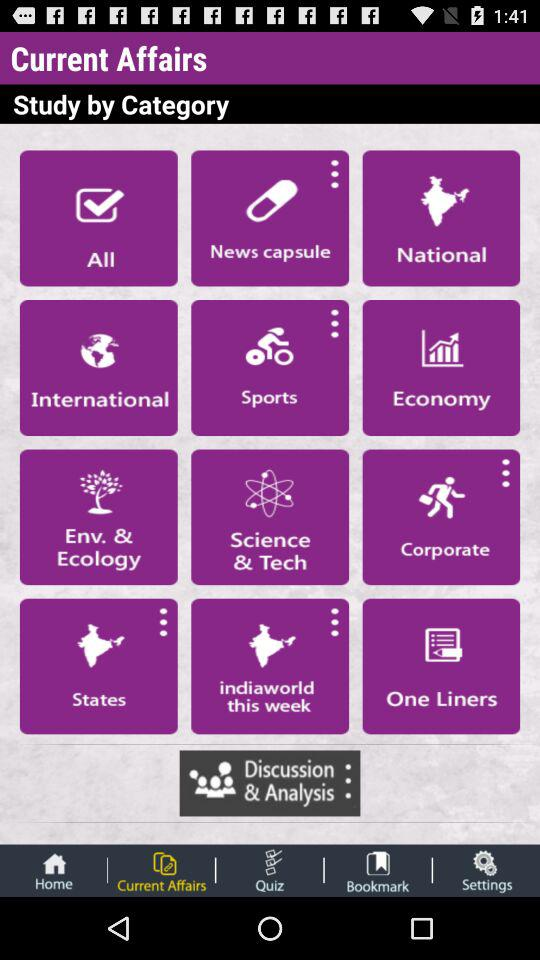Which option is selected? The selected option is "Current Affairs". 